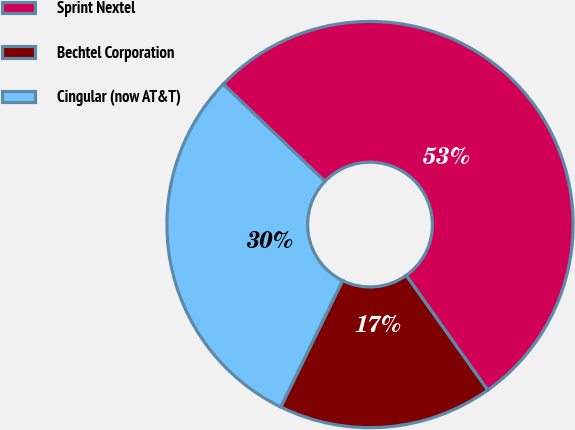Convert chart. <chart><loc_0><loc_0><loc_500><loc_500><pie_chart><fcel>Sprint Nextel<fcel>Bechtel Corporation<fcel>Cingular (now AT&T)<nl><fcel>53.02%<fcel>17.08%<fcel>29.9%<nl></chart> 